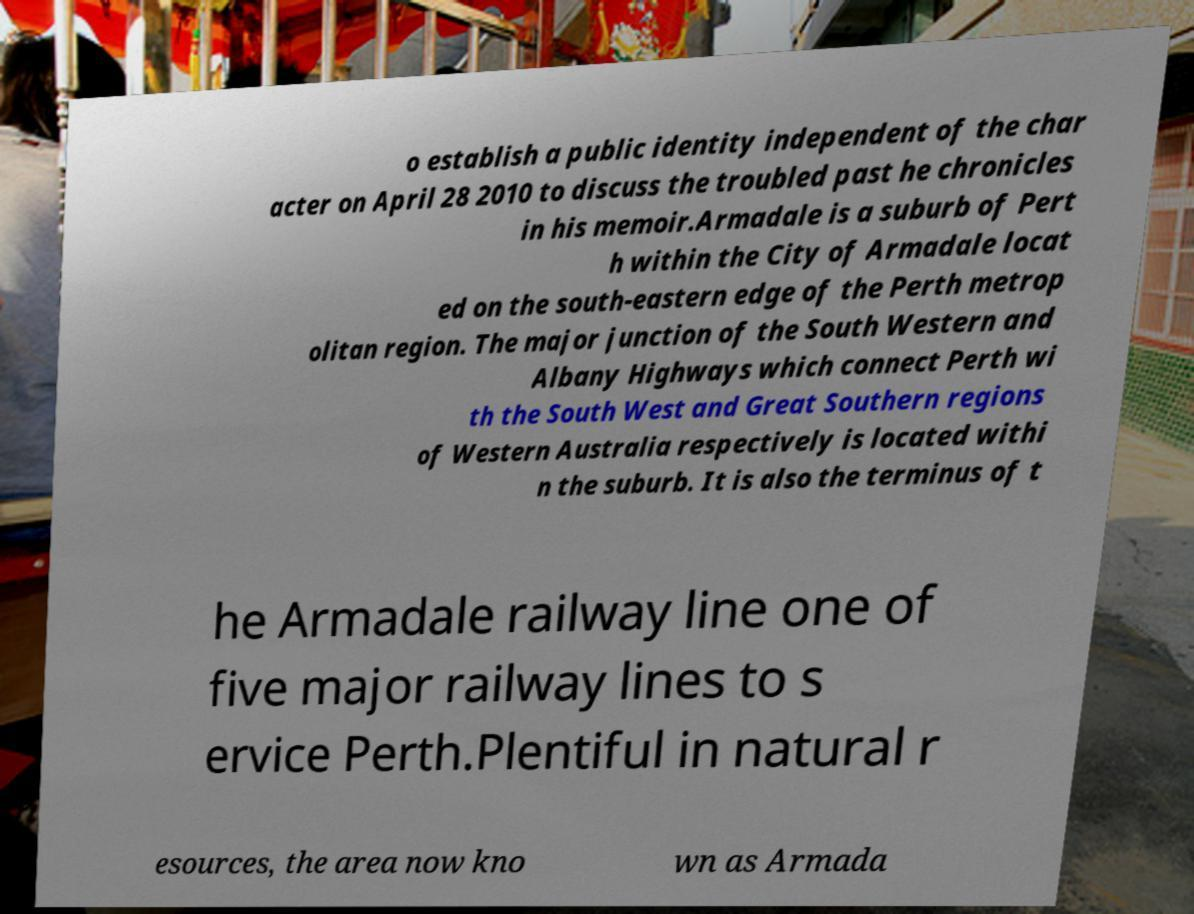Please read and relay the text visible in this image. What does it say? o establish a public identity independent of the char acter on April 28 2010 to discuss the troubled past he chronicles in his memoir.Armadale is a suburb of Pert h within the City of Armadale locat ed on the south-eastern edge of the Perth metrop olitan region. The major junction of the South Western and Albany Highways which connect Perth wi th the South West and Great Southern regions of Western Australia respectively is located withi n the suburb. It is also the terminus of t he Armadale railway line one of five major railway lines to s ervice Perth.Plentiful in natural r esources, the area now kno wn as Armada 